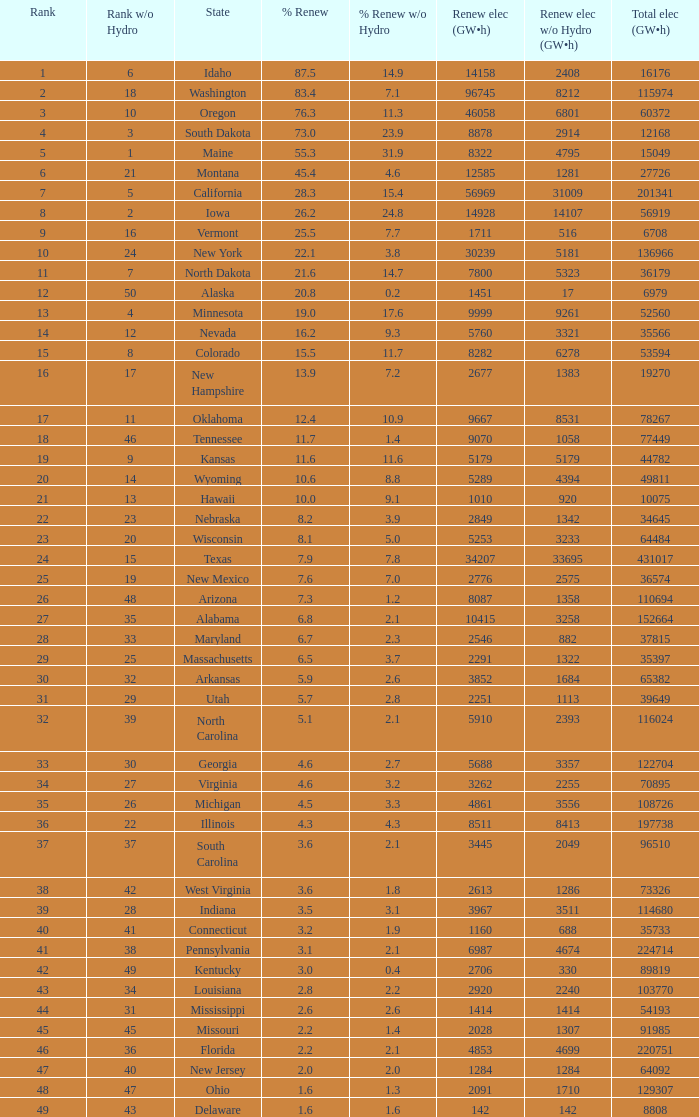What is the percentage of renewable electricity without hydrogen power in the state of South Dakota? 23.9. 